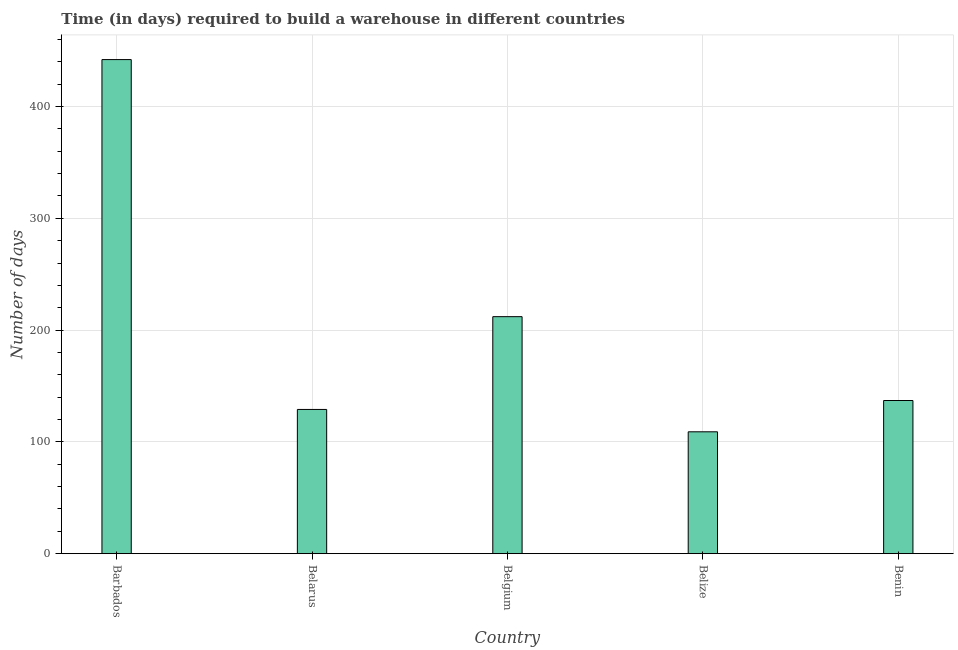Does the graph contain grids?
Your answer should be very brief. Yes. What is the title of the graph?
Keep it short and to the point. Time (in days) required to build a warehouse in different countries. What is the label or title of the X-axis?
Make the answer very short. Country. What is the label or title of the Y-axis?
Provide a succinct answer. Number of days. What is the time required to build a warehouse in Belarus?
Make the answer very short. 129. Across all countries, what is the maximum time required to build a warehouse?
Provide a short and direct response. 442. Across all countries, what is the minimum time required to build a warehouse?
Make the answer very short. 109. In which country was the time required to build a warehouse maximum?
Make the answer very short. Barbados. In which country was the time required to build a warehouse minimum?
Provide a short and direct response. Belize. What is the sum of the time required to build a warehouse?
Offer a terse response. 1029. What is the average time required to build a warehouse per country?
Your answer should be very brief. 205.8. What is the median time required to build a warehouse?
Give a very brief answer. 137. What is the ratio of the time required to build a warehouse in Barbados to that in Benin?
Your answer should be compact. 3.23. What is the difference between the highest and the second highest time required to build a warehouse?
Offer a terse response. 230. Is the sum of the time required to build a warehouse in Belize and Benin greater than the maximum time required to build a warehouse across all countries?
Offer a very short reply. No. What is the difference between the highest and the lowest time required to build a warehouse?
Your answer should be compact. 333. In how many countries, is the time required to build a warehouse greater than the average time required to build a warehouse taken over all countries?
Give a very brief answer. 2. How many countries are there in the graph?
Keep it short and to the point. 5. Are the values on the major ticks of Y-axis written in scientific E-notation?
Your response must be concise. No. What is the Number of days in Barbados?
Make the answer very short. 442. What is the Number of days of Belarus?
Give a very brief answer. 129. What is the Number of days in Belgium?
Provide a succinct answer. 212. What is the Number of days in Belize?
Provide a short and direct response. 109. What is the Number of days in Benin?
Keep it short and to the point. 137. What is the difference between the Number of days in Barbados and Belarus?
Offer a very short reply. 313. What is the difference between the Number of days in Barbados and Belgium?
Keep it short and to the point. 230. What is the difference between the Number of days in Barbados and Belize?
Offer a very short reply. 333. What is the difference between the Number of days in Barbados and Benin?
Offer a terse response. 305. What is the difference between the Number of days in Belarus and Belgium?
Provide a succinct answer. -83. What is the difference between the Number of days in Belarus and Benin?
Offer a very short reply. -8. What is the difference between the Number of days in Belgium and Belize?
Keep it short and to the point. 103. What is the difference between the Number of days in Belgium and Benin?
Ensure brevity in your answer.  75. What is the ratio of the Number of days in Barbados to that in Belarus?
Your answer should be compact. 3.43. What is the ratio of the Number of days in Barbados to that in Belgium?
Offer a very short reply. 2.08. What is the ratio of the Number of days in Barbados to that in Belize?
Ensure brevity in your answer.  4.05. What is the ratio of the Number of days in Barbados to that in Benin?
Provide a short and direct response. 3.23. What is the ratio of the Number of days in Belarus to that in Belgium?
Provide a short and direct response. 0.61. What is the ratio of the Number of days in Belarus to that in Belize?
Provide a short and direct response. 1.18. What is the ratio of the Number of days in Belarus to that in Benin?
Make the answer very short. 0.94. What is the ratio of the Number of days in Belgium to that in Belize?
Provide a succinct answer. 1.95. What is the ratio of the Number of days in Belgium to that in Benin?
Offer a terse response. 1.55. What is the ratio of the Number of days in Belize to that in Benin?
Offer a terse response. 0.8. 